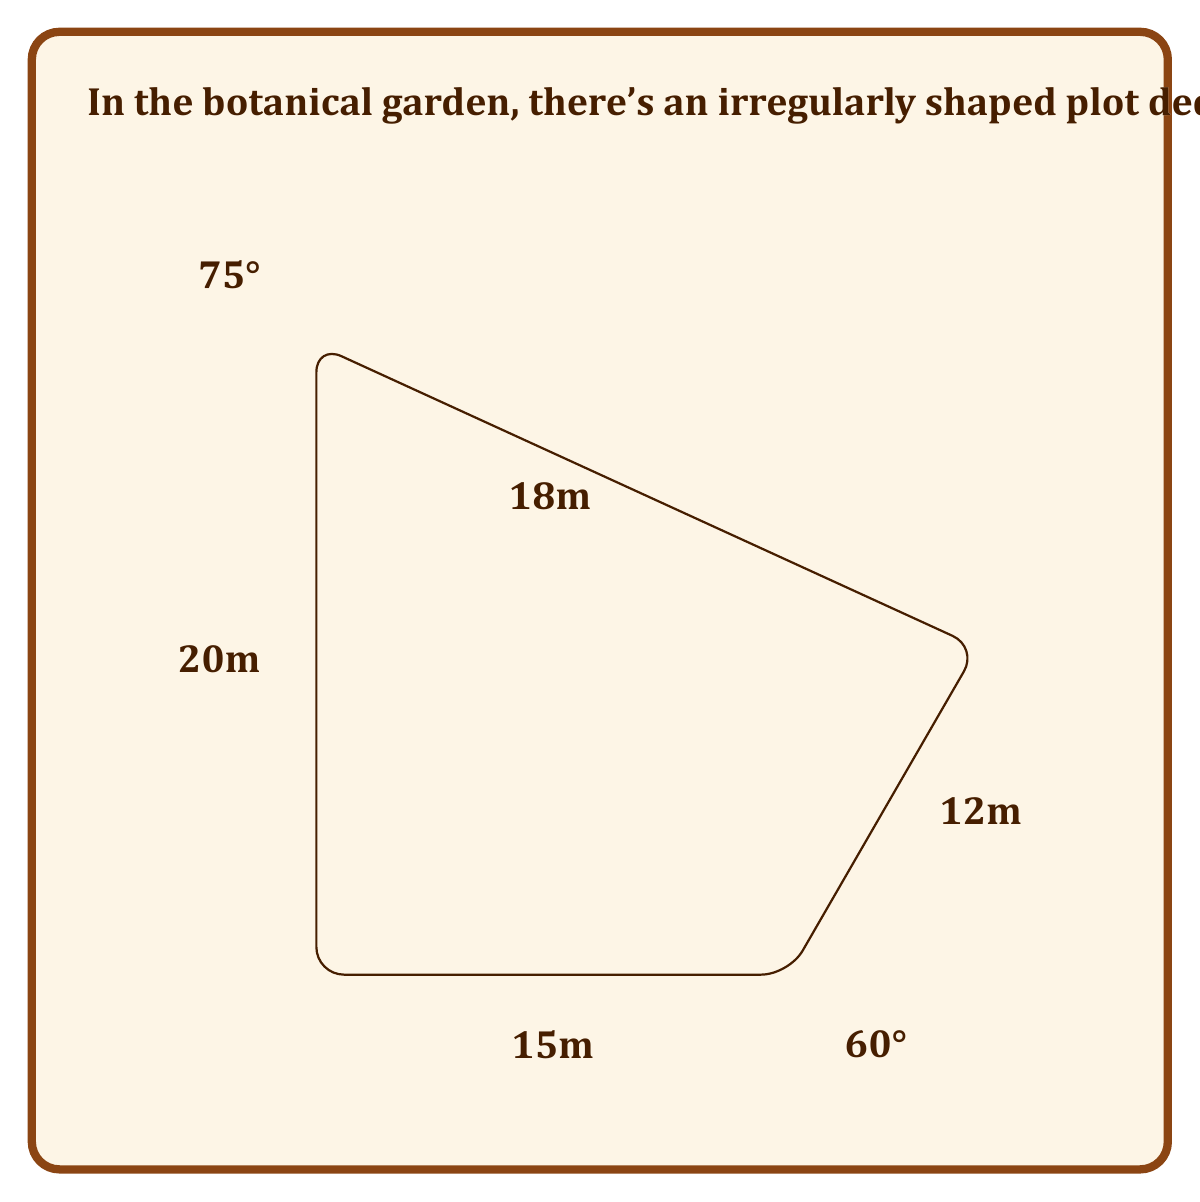Provide a solution to this math problem. To find the area of this irregular quadrilateral, we can split it into two triangles and use trigonometric formulas. Let's approach this step-by-step:

1) First, let's split the quadrilateral into two triangles: ABC and ACD.

2) For triangle ABC:
   - We know two sides (15m and 12m) and the included angle (60°).
   - We can use the formula: Area = $\frac{1}{2}ab\sin(C)$
   - Area of ABC = $\frac{1}{2} \cdot 15 \cdot 12 \cdot \sin(60°)$
   - $\sin(60°) = \frac{\sqrt{3}}{2}$
   - Area of ABC = $\frac{1}{2} \cdot 15 \cdot 12 \cdot \frac{\sqrt{3}}{2} = 45\sqrt{3}$ m²

3) For triangle ACD:
   - We know two sides (18m and 20m) and the included angle (75°).
   - Using the same formula: Area = $\frac{1}{2}ab\sin(C)$
   - Area of ACD = $\frac{1}{2} \cdot 18 \cdot 20 \cdot \sin(75°)$
   - $\sin(75°) = \frac{\sqrt{6}+\sqrt{2}}{4}$
   - Area of ACD = $\frac{1}{2} \cdot 18 \cdot 20 \cdot \frac{\sqrt{6}+\sqrt{2}}{4} = 45(\sqrt{6}+\sqrt{2})$ m²

4) The total area is the sum of these two triangles:
   Total Area = $45\sqrt{3} + 45(\sqrt{6}+\sqrt{2})$ m²

5) Simplifying:
   $45\sqrt{3} + 45\sqrt{6} + 45\sqrt{2}$
   $= 45(\sqrt{3} + \sqrt{6} + \sqrt{2})$
   $\approx 321.39$ m²

6) Rounding to the nearest square meter:
   Area ≈ 321 m²
Answer: 321 m² 